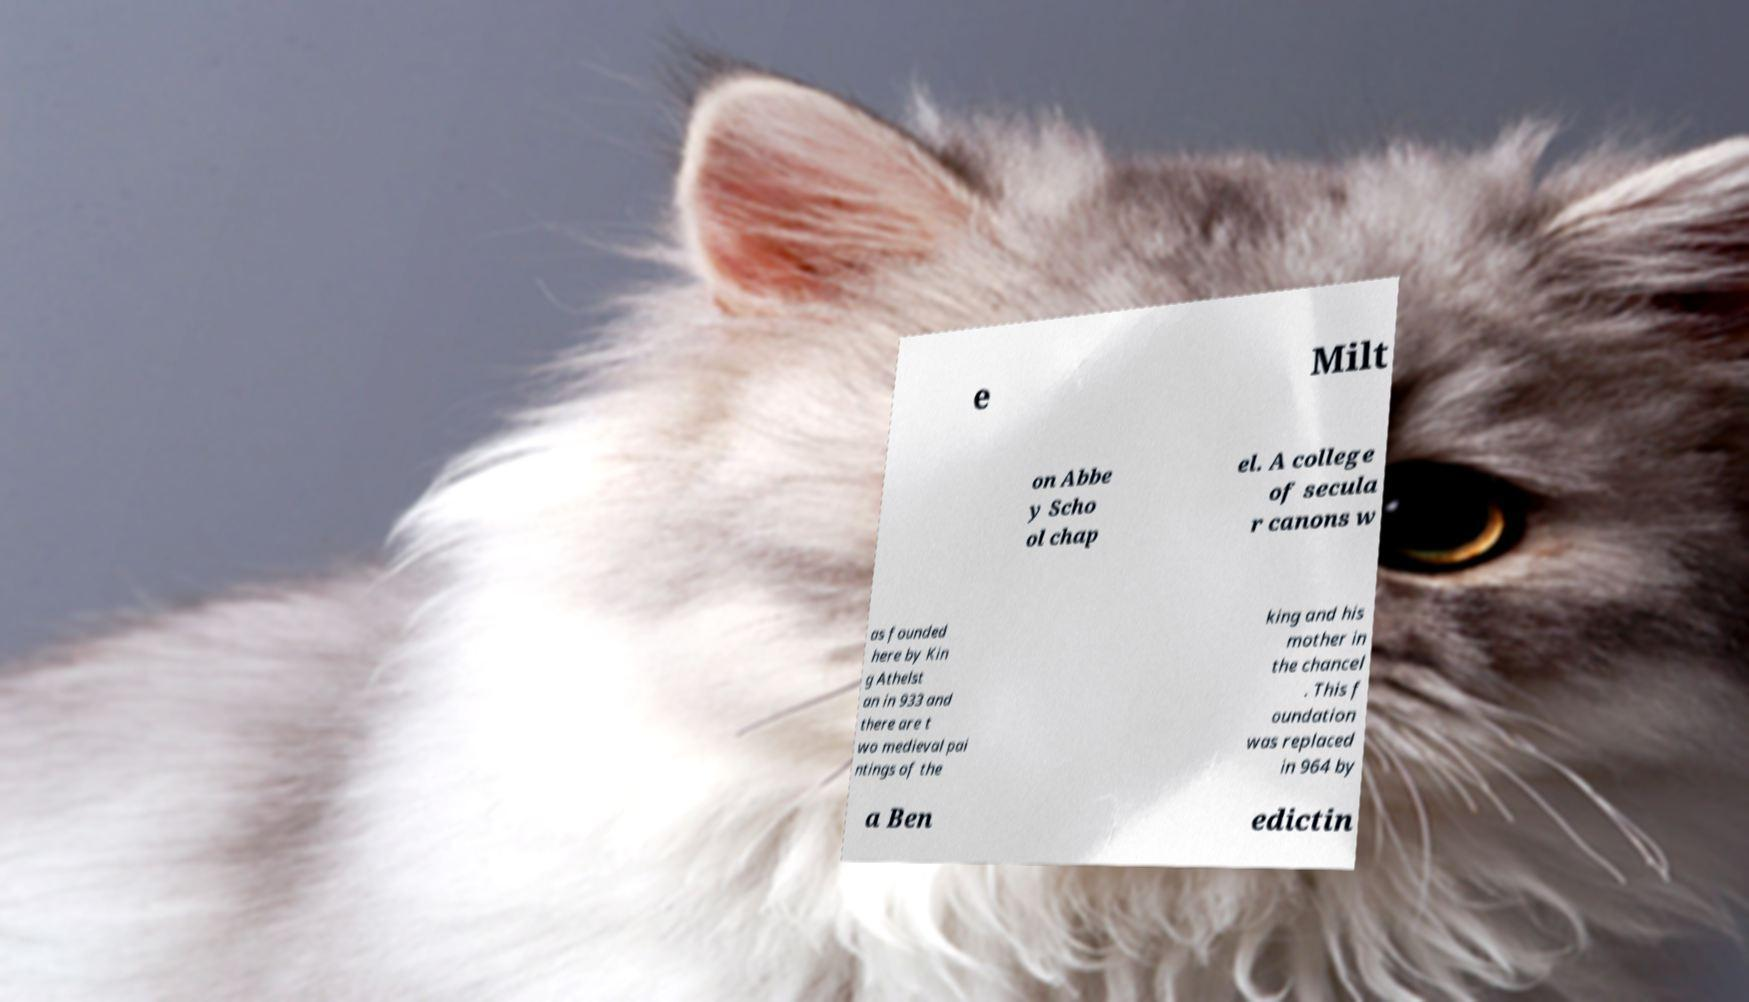I need the written content from this picture converted into text. Can you do that? e Milt on Abbe y Scho ol chap el. A college of secula r canons w as founded here by Kin g Athelst an in 933 and there are t wo medieval pai ntings of the king and his mother in the chancel . This f oundation was replaced in 964 by a Ben edictin 